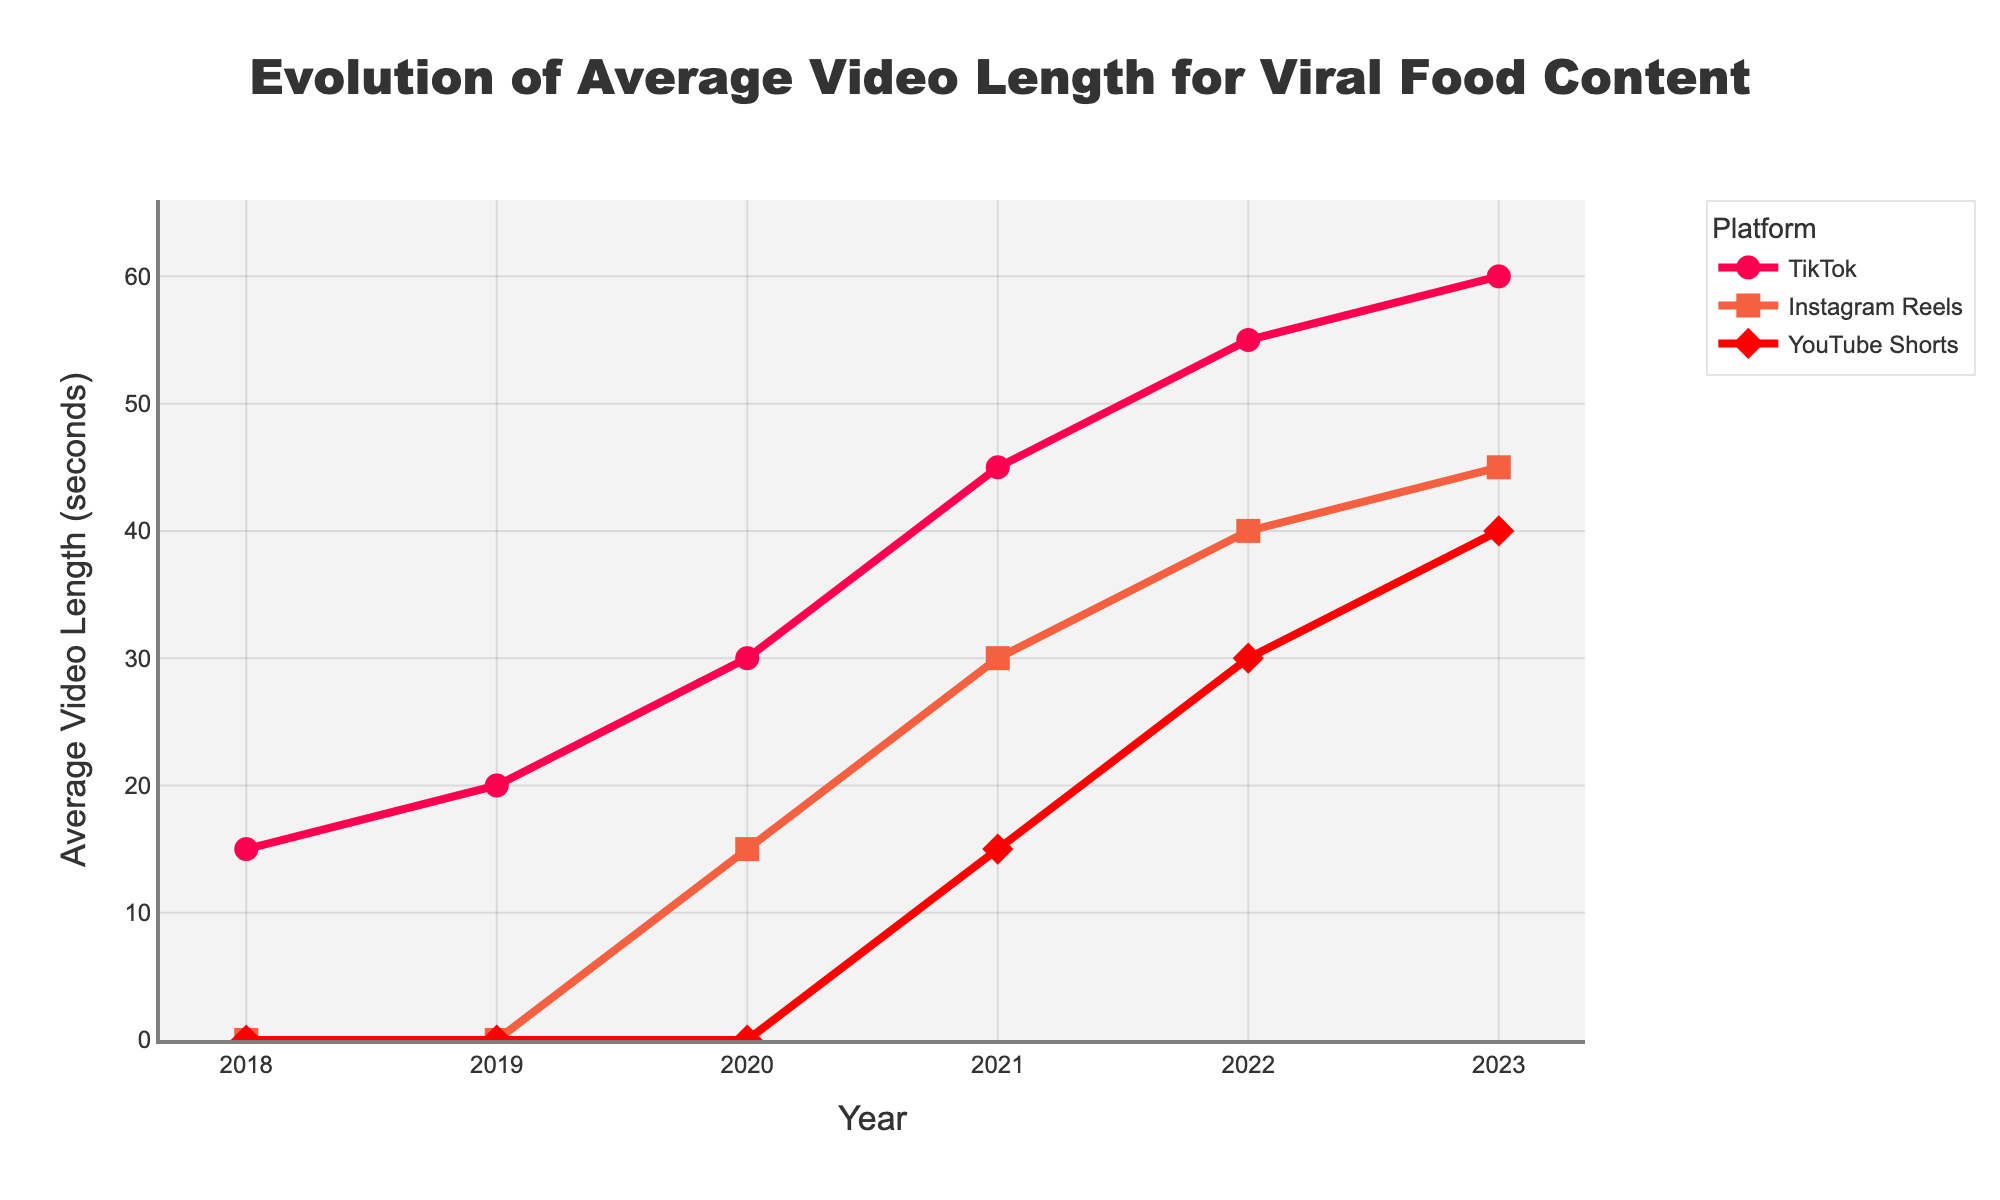What's the trend for TikTok average video lengths over the years? Analyze the trajectory of the red line representing TikTok in the graph, we see it rising steadily from 2018 to 2023.
Answer: Increasing trend How do the video lengths for Instagram Reels in 2020 compare to those for YouTube Shorts in the same year? Locate the points for Instagram Reels and YouTube Shorts in 2020. Instagram Reels is at 15 seconds, while YouTube Shorts is at 0 seconds.
Answer: Instagram Reels: 15, YouTube Shorts: 0 What is the difference between the average video lengths on TikTok and YouTube Shorts in 2023? In 2023, TikTok's average video length is 60 seconds and YouTube Shorts is 40 seconds. Subtract 40 from 60 to get the difference.
Answer: 20 seconds Which platform showed the most significant increase in video length from 2021 to 2022? Calculate the increase for each platform: TikTok (55 - 45 = 10), Instagram Reels (40 - 30 = 10), and YouTube Shorts (30 - 15 = 15). YouTube Shorts exhibits the highest increase.
Answer: YouTube Shorts What was the average video length for Instagram Reels in 2018? Look at the corresponding mark for Instagram Reels in 2018 which is 0.
Answer: 0 seconds In 2022, which platform had the shortest average video length? Check the lengths for all platforms in 2022: Instagram Reels (40), YouTube Shorts (30), TikTok (55). The shortest is YouTube Shorts at 30 seconds.
Answer: YouTube Shorts By how much did Instagram Reels' average video length increase from 2020 to 2023? In 2020, Instagram Reels is at 15 seconds; in 2023, it is at 45 seconds. The increase is 45 - 15 = 30.
Answer: 30 seconds What color and shape are used to represent TikTok's data points? Observing the figure, the TikTok data points are depicted in red circles.
Answer: Red and circles Which year did YouTube Shorts first appear in the data, and what was the average video length? YouTube Shorts first appears in the year 2021 with an average video length of 15 seconds.
Answer: 2021, 15 seconds 